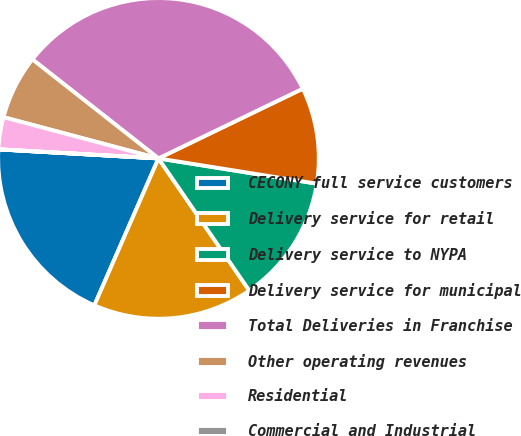Convert chart. <chart><loc_0><loc_0><loc_500><loc_500><pie_chart><fcel>CECONY full service customers<fcel>Delivery service for retail<fcel>Delivery service to NYPA<fcel>Delivery service for municipal<fcel>Total Deliveries in Franchise<fcel>Other operating revenues<fcel>Residential<fcel>Commercial and Industrial<nl><fcel>19.35%<fcel>16.13%<fcel>12.9%<fcel>9.68%<fcel>32.24%<fcel>6.46%<fcel>3.23%<fcel>0.01%<nl></chart> 